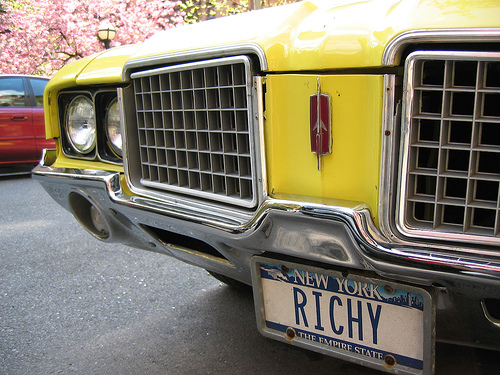<image>
Is the car under the tree? Yes. The car is positioned underneath the tree, with the tree above it in the vertical space. 